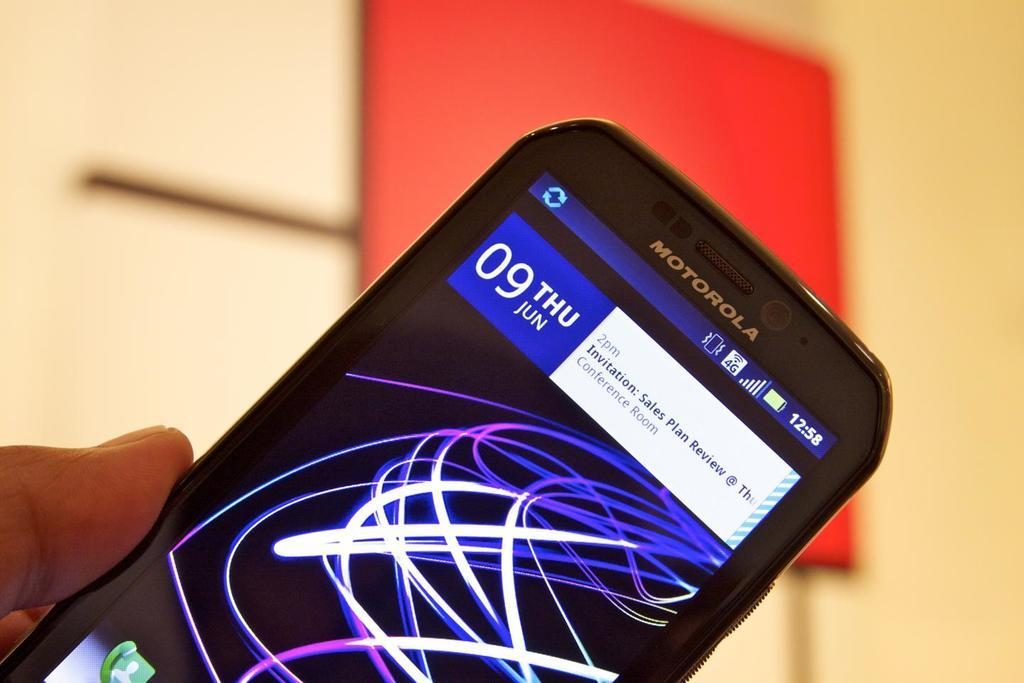<image>
Write a terse but informative summary of the picture. A Motorola phone is turned on to the home screen where an invitation to attend a sales plan review is displayed. 